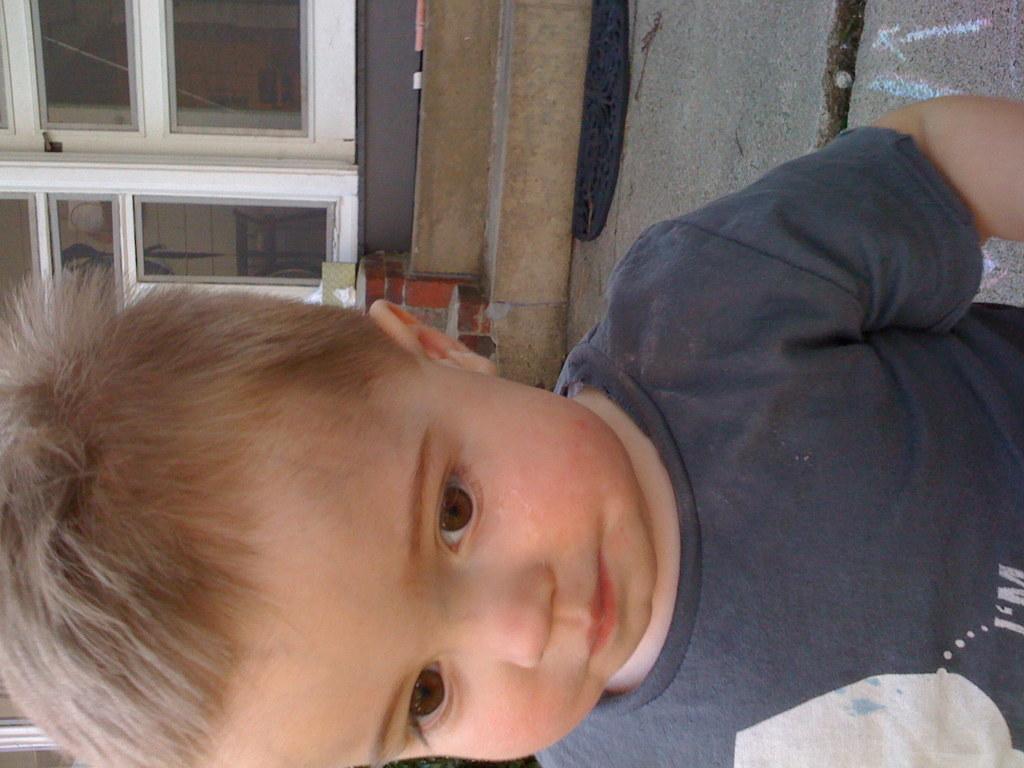Please provide a concise description of this image. In this image, I can see a boy. At the top of the image, I can see a door, stairs and a floor mat on the floor. 